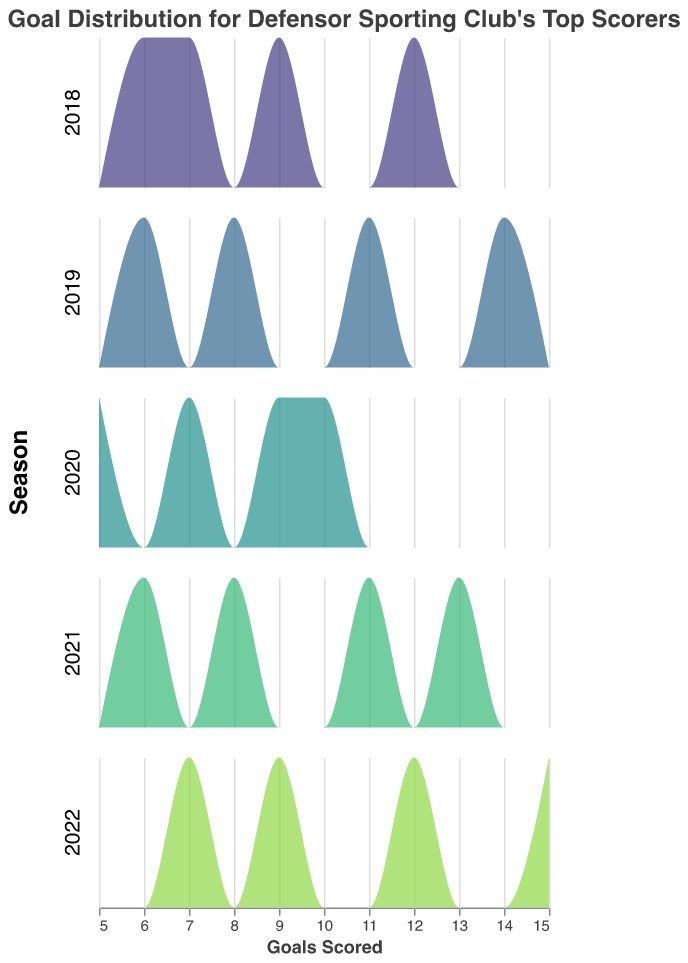What title is displayed on the figure? The title of the figure is usually located at the top and explicitly describes the content or purpose of the visualization. In this case, it reads "Goal Distribution for Defensor Sporting Club's Top Scorers".
Answer: Goal Distribution for Defensor Sporting Club's Top Scorers How many density plots are present in the figure? Each season is represented by one density plot in the subplot. Since there are density plots for each season from 2018 to 2022, there are five density plots in the figure.
Answer: Five Which player had the highest number of goals in 2022, according to the density plot? By examining the peak of the density plot for 2022, we see that Facundo Castro scored the highest with the maximum density around a goal count of 15.
Answer: Facundo Castro What is the range of goals scored by players in the 2020 season? The density plot for the 2020 season shows the spread of goal counts. The range of goals is derived from the minimum and maximum goal values, which from the density plot look to span from 5 to approximately 10 goals.
Answer: 5 to 10 Which season had the highest goal count recorded by any top scorer and who was that player? By reviewing the highest peaks across all density plots, we can see that the 2022 season has the highest goal count of 15, recorded by Facundo Castro.
Answer: 2022, Facundo Castro How does the goal distribution in 2021 compare to the goal distribution in 2019? Compare the density plots for 2021 and 2019 to see where the peaks (most common values in the data) and ranges lie. 2021 shows higher goal counts with peaks around 11 to 13 goals, whereas 2019 has peaks around 8 to 14 goals.
Answer: 2021 had higher goal counts relative to the peak goals in 2019 Which year shows the most tightly clustered goal distribution around a central value? A more tightly clustered goal distribution would have a sharper peak and less spread. Analyzing the plots, the 2020 season has a relatively sharp peak around 9-10 goals, indicating closely clustered goal distribution around that central value.
Answer: 2020 How many players scored 7 goals in the 2018 season? Referring to the density plot for the 2018 season, there is only a single peak at a goal count of 7, indicating one player scored 7 goals in that year.
Answer: One What is the average number of goals scored by top players in 2019? Calculate the average by summing the goals of all top players in 2019 and dividing by the number of players: (14 + 11 + 8 + 6) / 4 = 39 / 4 = 9.75.
Answer: 9.75 